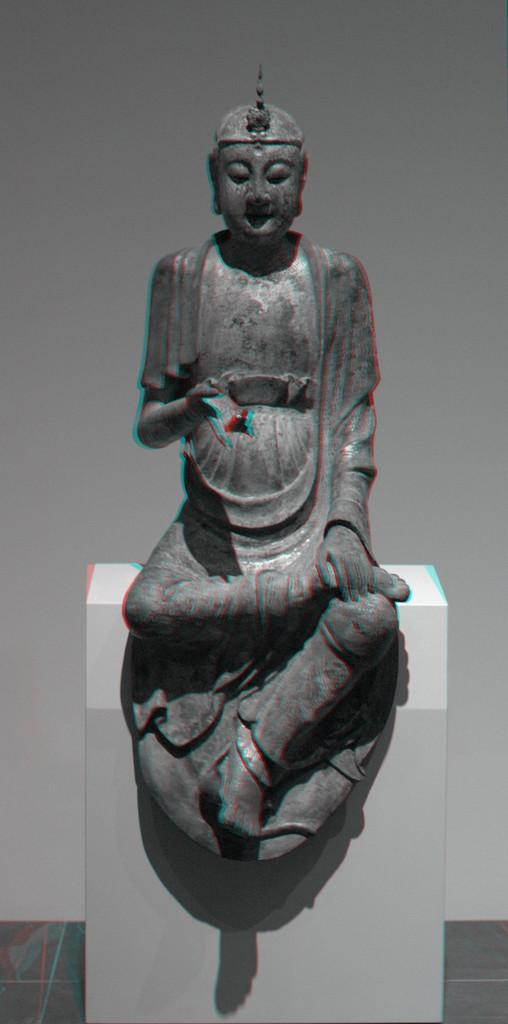What is the color scheme of the image? The image is black and white. What is the main subject of the image? There is a Buddha sculpture in the image. What is the sculpture placed on? The Buddha sculpture is placed on a white surface. What type of frog can be seen sitting on the Buddha sculpture in the image? There is no frog present on the Buddha sculpture in the image. What type of beef is being served on a plate next to the Buddha sculpture in the image? There is no beef or plate present in the image; it only features a black and white Buddha sculpture on a white surface. 